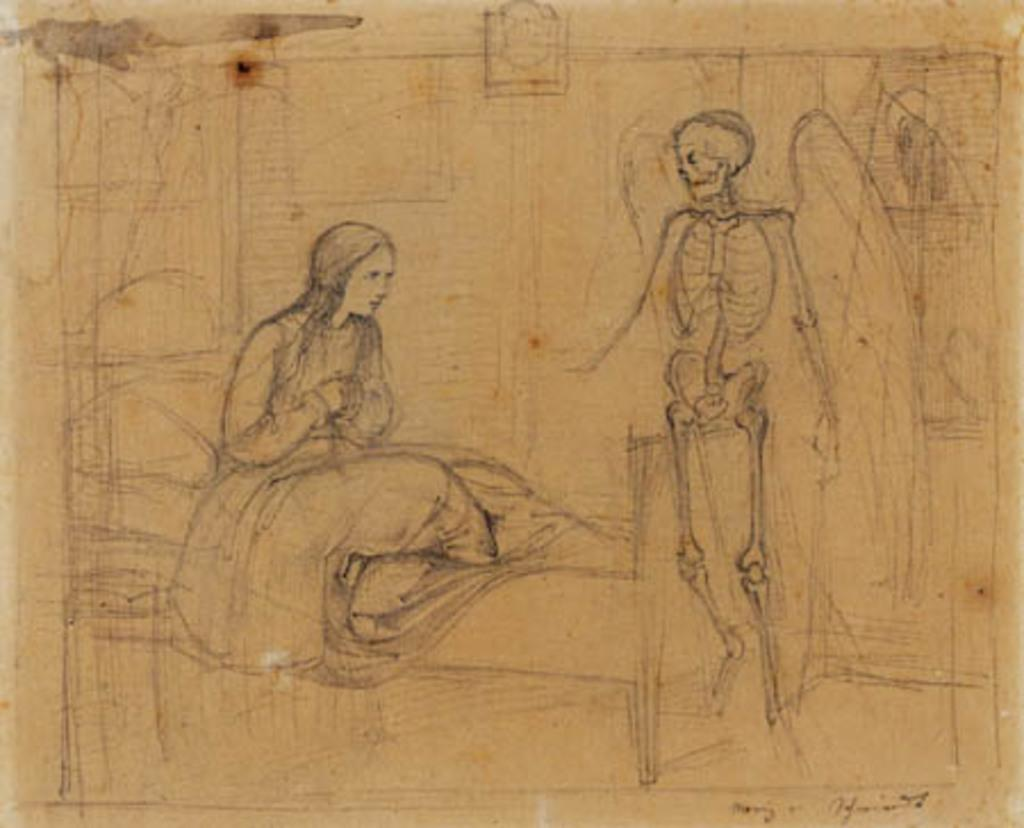What type of artwork is depicted in the image? The image is a drawing. What piece of furniture is present in the drawing? There is a cot in the drawing. Who is sitting on the cot in the drawing? A lady is sitting on the cot in the drawing. What other object can be seen in the drawing? There is a skeleton in the drawing. Can you tell me how many baseballs are in the drawing? There are no baseballs present in the drawing; it features a cot, a lady, and a skeleton. Is the lady jumping in the drawing? There is no indication that the lady is jumping in the drawing; she is sitting on the cot. 